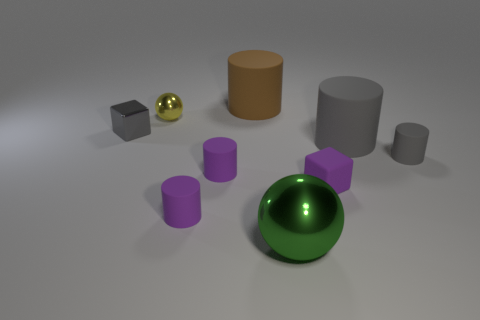There is a large matte thing behind the yellow thing; is it the same shape as the gray thing left of the tiny matte block?
Your response must be concise. No. How many large cylinders are both right of the large metallic ball and behind the small gray block?
Your answer should be very brief. 0. Is there a small metallic object of the same color as the big sphere?
Your response must be concise. No. What is the shape of the shiny thing that is the same size as the yellow sphere?
Offer a terse response. Cube. There is a small gray cube; are there any gray cylinders on the left side of it?
Keep it short and to the point. No. Are the small gray object that is on the right side of the small matte block and the cube that is right of the green metallic ball made of the same material?
Your response must be concise. Yes. What number of yellow balls are the same size as the green thing?
Offer a very short reply. 0. What is the shape of the large rubber thing that is the same color as the tiny metallic cube?
Your answer should be compact. Cylinder. What is the cylinder that is in front of the purple cube made of?
Provide a short and direct response. Rubber. What number of other large gray rubber things have the same shape as the big gray rubber object?
Offer a very short reply. 0. 